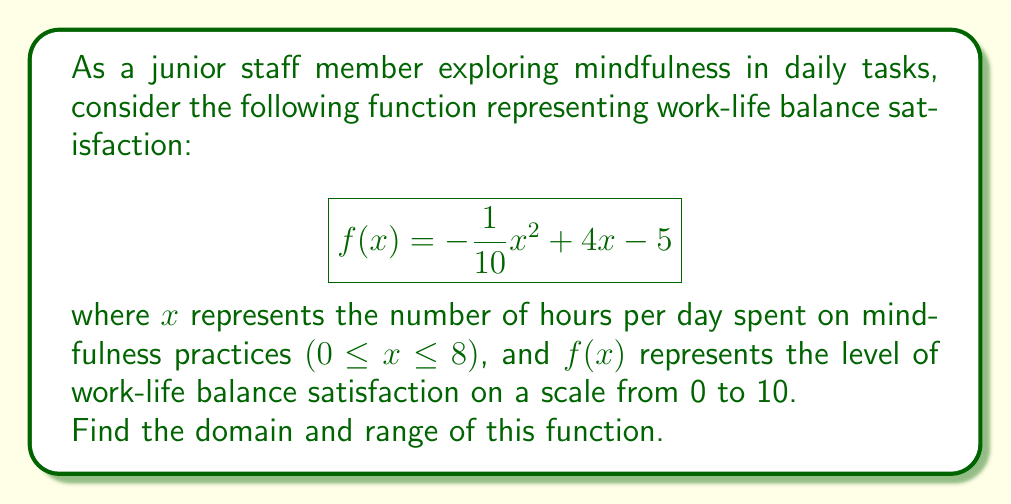What is the answer to this math problem? To find the domain and range of this function, we'll follow these steps:

1. Domain:
   The domain is given in the question as 0 ≤ x ≤ 8, representing the realistic range of hours one might spend on mindfulness practices per day.

2. Range:
   To find the range, we need to determine the minimum and maximum values of f(x) within the given domain.

   a) First, let's find the vertex of the parabola:
      $$x = -\frac{b}{2a} = -\frac{4}{2(-\frac{1}{10})} = 20$$

      However, this is outside our domain. The maximum value will occur at the upper bound of our domain, x = 8.

   b) Calculate f(0) and f(8):
      $$f(0) = -\frac{1}{10}(0)^2 + 4(0) - 5 = -5$$
      $$f(8) = -\frac{1}{10}(8)^2 + 4(8) - 5 = -6.4 + 32 - 5 = 20.6$$

   c) Since this is a downward-opening parabola (a < 0), the function will be increasing throughout our domain.

   d) The minimum value is f(0) = -5, but since our satisfaction scale is from 0 to 10, we'll adjust this to 0.

   e) The maximum value is f(8) = 20.6, but we'll cap this at 10 to stay within our satisfaction scale.

Therefore, the range is [0, 10].
Answer: Domain: [0, 8]
Range: [0, 10] 